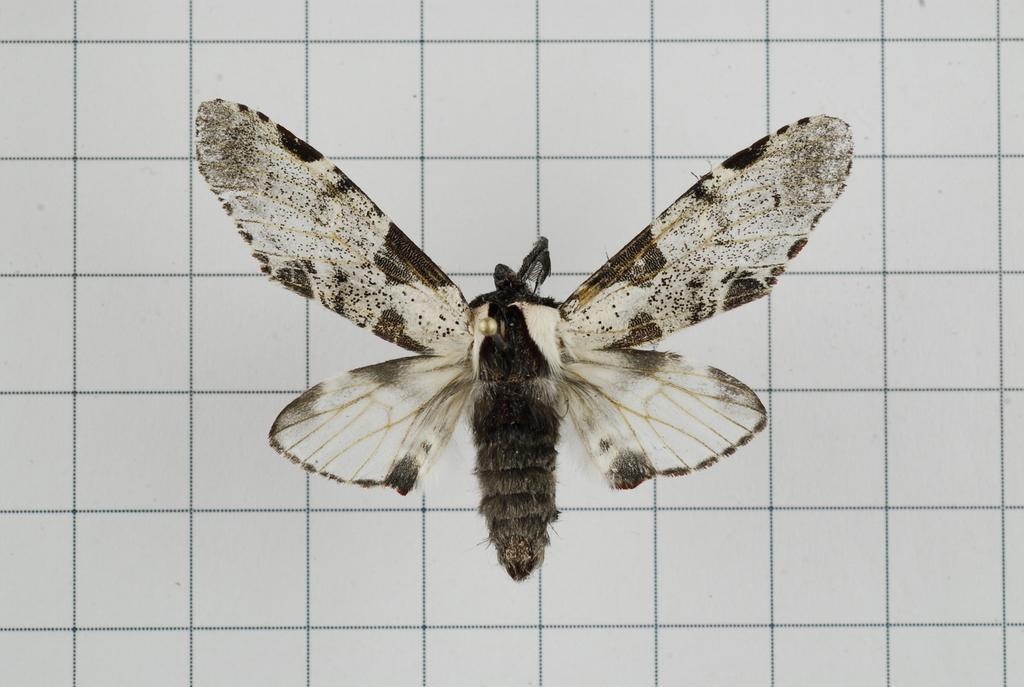Please provide a concise description of this image. In this picture I can see a butterfly and looks like tiles in the background. 